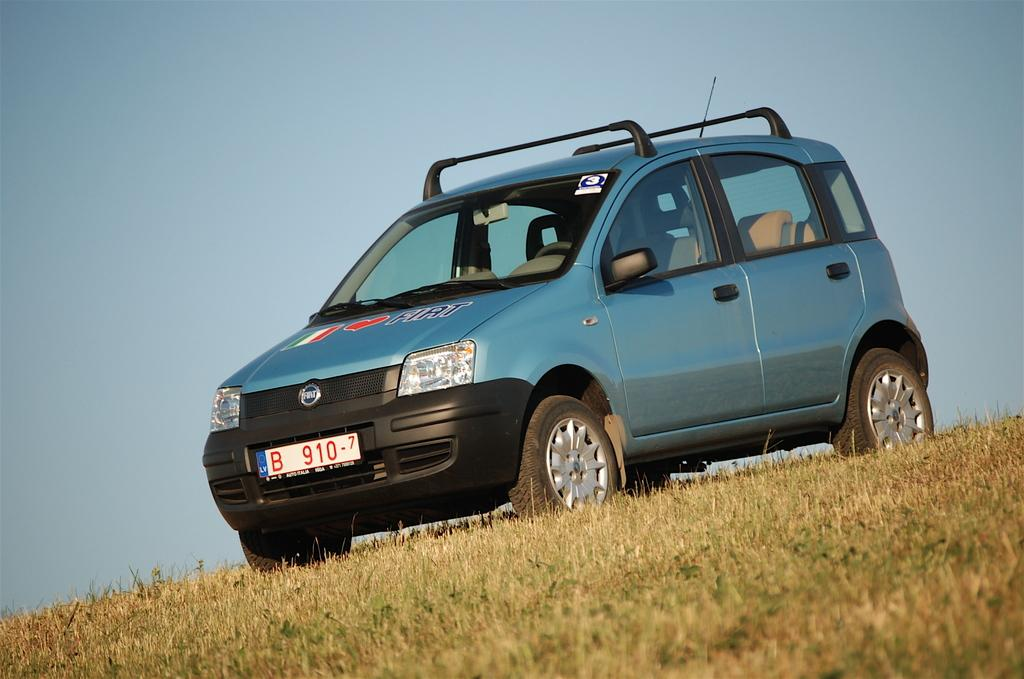What is the main subject of the image? The main subject of the image is a car. Where is the car located in the image? The car is on the grass. What can be seen in the background of the image? The sky is visible in the background of the image. How many doors can be seen on the car in the image? The number of doors on the car cannot be determined from the image, as the doors are not visible. What type of line is present in the image? There is no line present in the image. What emotion is being expressed by the car in the image? Cars do not express emotions, so this question cannot be answered definitively. 